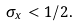<formula> <loc_0><loc_0><loc_500><loc_500>\sigma _ { x } < 1 / 2 .</formula> 